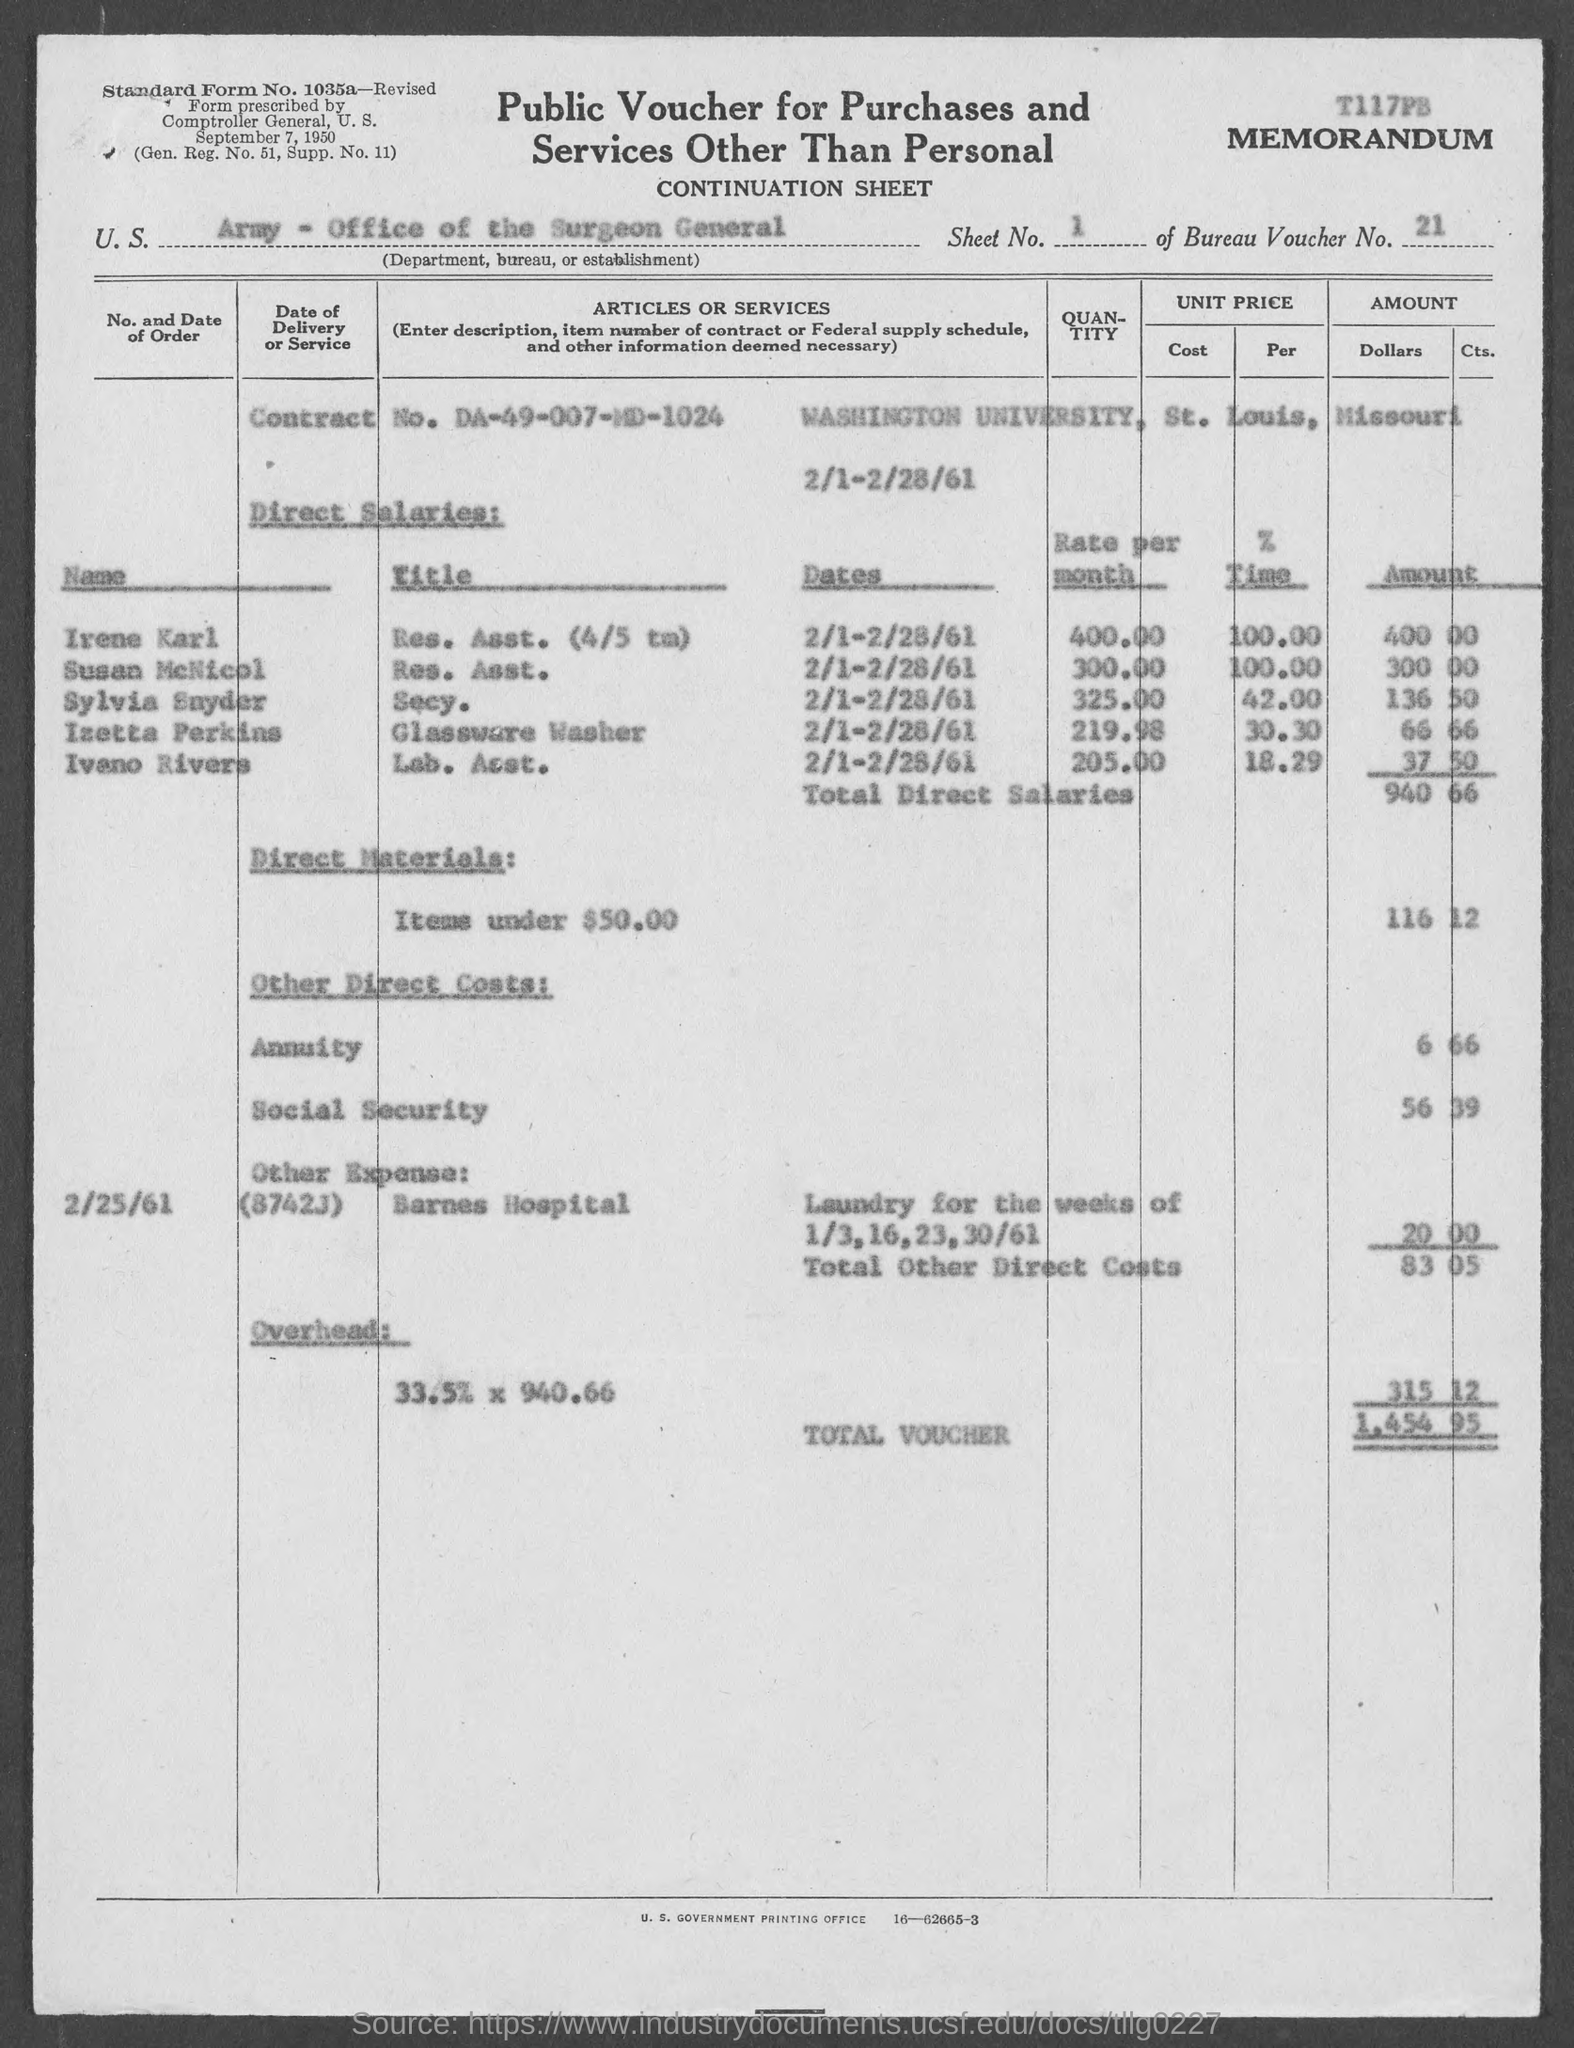What type of voucher is given here?
Offer a terse response. Public Voucher for Purchases and Services other than Personal. What is the Standard Form No. given in the voucher?
Make the answer very short. 1035a. What is the U.S. Department, Bureau, or Establishment given in the voucher?
Make the answer very short. Army - Office of the Surgeon General. What is the Sheet No. mentioned in the voucher?
Ensure brevity in your answer.  1. What is the Bureau Voucher No. given in the document?
Offer a very short reply. 21. What is the Contract No. given in the voucher?
Offer a very short reply. DA-49-007-MD-1024. What is the Direct material cost (Items under $50) given in the voucher?
Provide a succinct answer. 116 12. What is the direct salaries cost mentioned in the voucher?
Give a very brief answer. $ 940.66. What is the total voucher amount mentioned in the document?
Make the answer very short. 1,454.95. What is the social security cost mentioned in the voucher?
Your answer should be very brief. $ 56.39. 